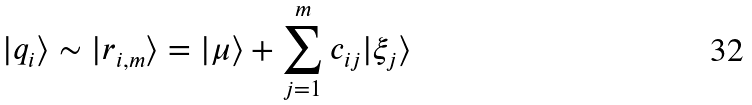Convert formula to latex. <formula><loc_0><loc_0><loc_500><loc_500>| q _ { i } \rangle \sim | r _ { i , m } \rangle = | \mu \rangle + \sum _ { j = 1 } ^ { m } c _ { i j } | \xi _ { j } \rangle</formula> 